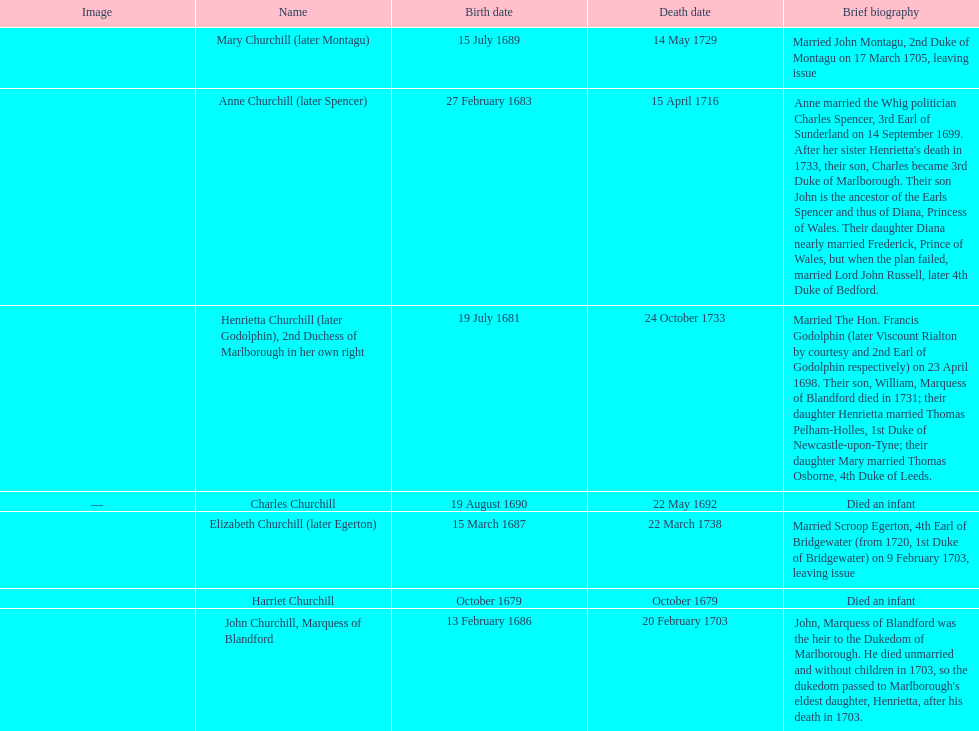Which child was the first to die? Harriet Churchill. 